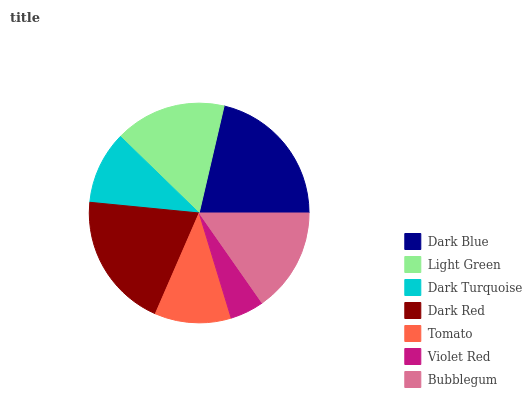Is Violet Red the minimum?
Answer yes or no. Yes. Is Dark Blue the maximum?
Answer yes or no. Yes. Is Light Green the minimum?
Answer yes or no. No. Is Light Green the maximum?
Answer yes or no. No. Is Dark Blue greater than Light Green?
Answer yes or no. Yes. Is Light Green less than Dark Blue?
Answer yes or no. Yes. Is Light Green greater than Dark Blue?
Answer yes or no. No. Is Dark Blue less than Light Green?
Answer yes or no. No. Is Bubblegum the high median?
Answer yes or no. Yes. Is Bubblegum the low median?
Answer yes or no. Yes. Is Violet Red the high median?
Answer yes or no. No. Is Dark Red the low median?
Answer yes or no. No. 